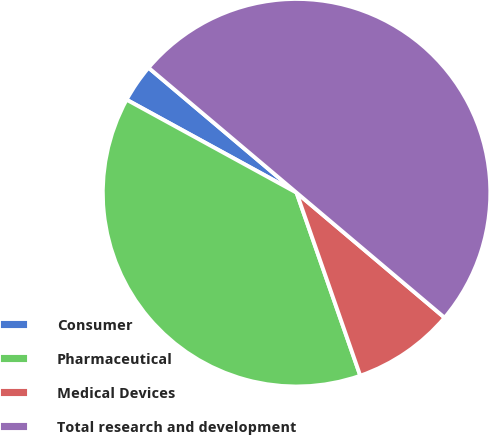Convert chart to OTSL. <chart><loc_0><loc_0><loc_500><loc_500><pie_chart><fcel>Consumer<fcel>Pharmaceutical<fcel>Medical Devices<fcel>Total research and development<nl><fcel>3.19%<fcel>38.3%<fcel>8.51%<fcel>50.0%<nl></chart> 